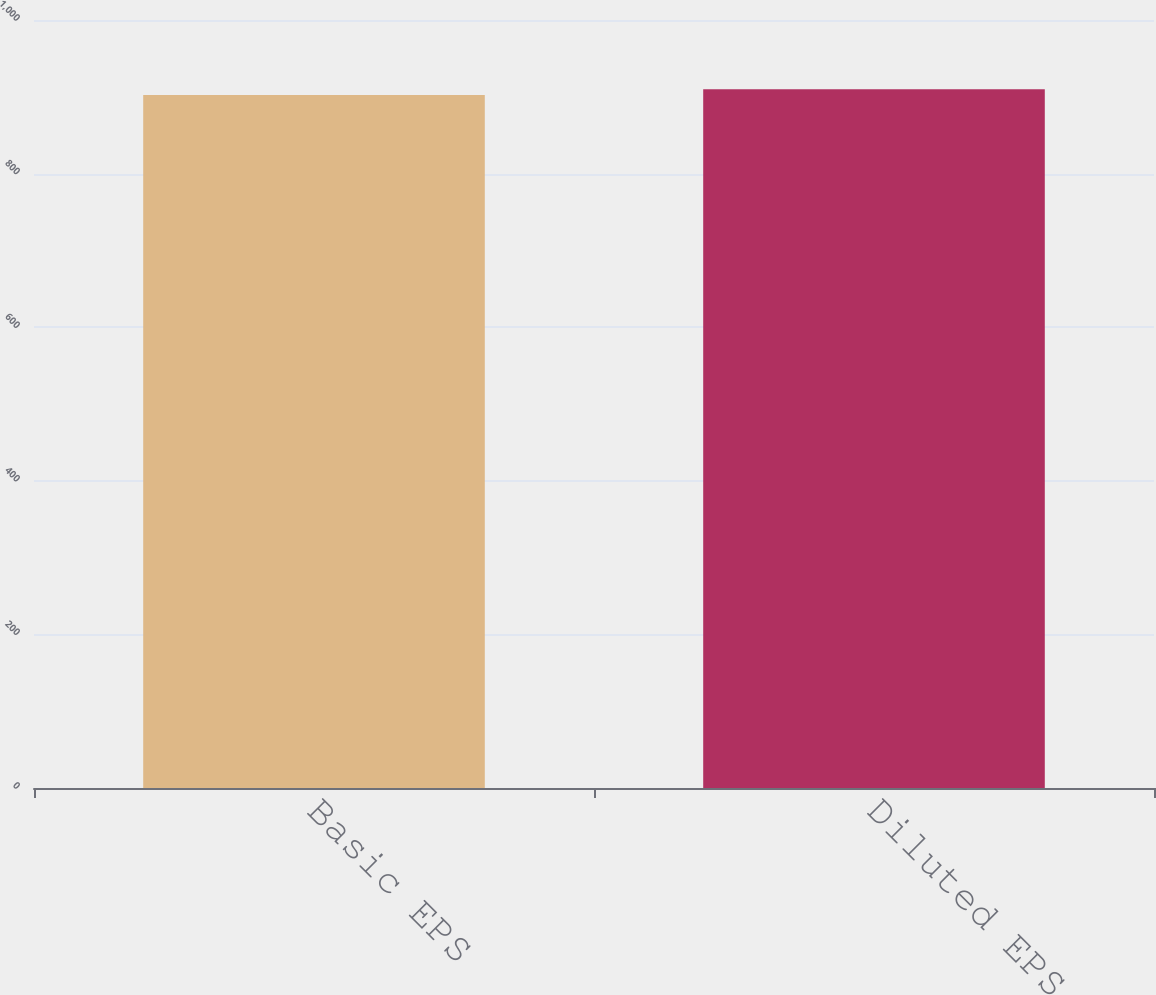Convert chart to OTSL. <chart><loc_0><loc_0><loc_500><loc_500><bar_chart><fcel>Basic EPS<fcel>Diluted EPS<nl><fcel>902.2<fcel>909.7<nl></chart> 